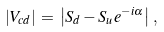<formula> <loc_0><loc_0><loc_500><loc_500>| V _ { c d } | \, = \, \left | S _ { d } - S _ { u } e ^ { - i \alpha } \right | \, ,</formula> 